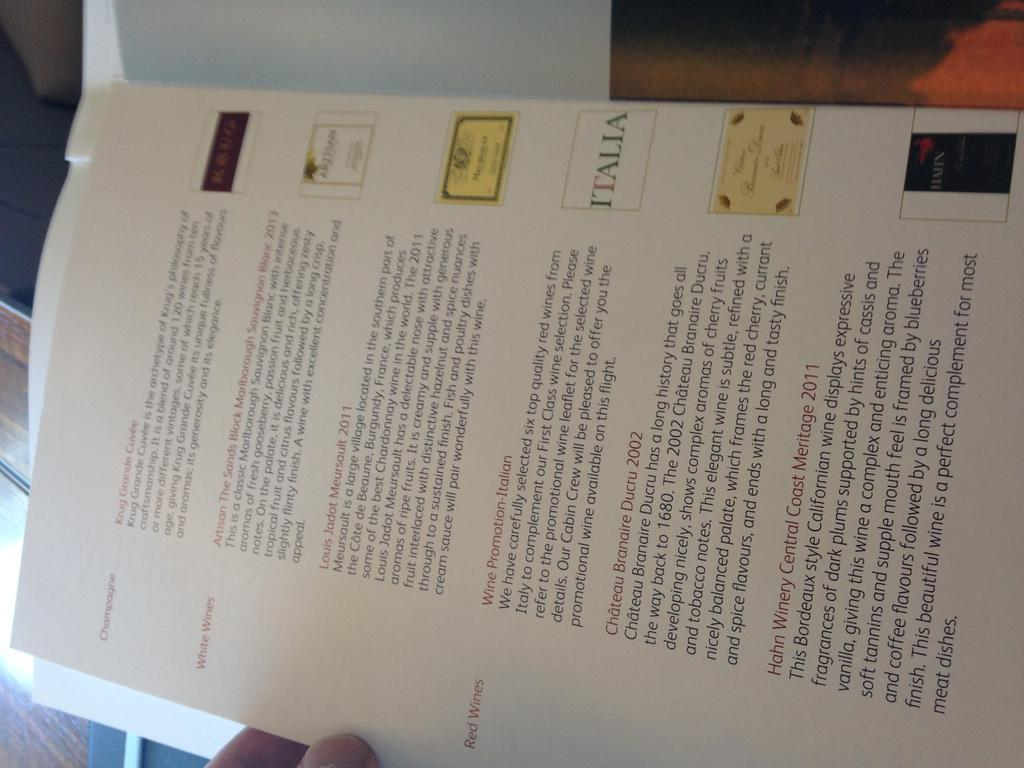What is present in the image? There is a person in the image. What is the person holding? The person is holding a paper. What type of pets does the person have in the image? There is no mention of pets in the image, so it cannot be determined if the person has any pets. 